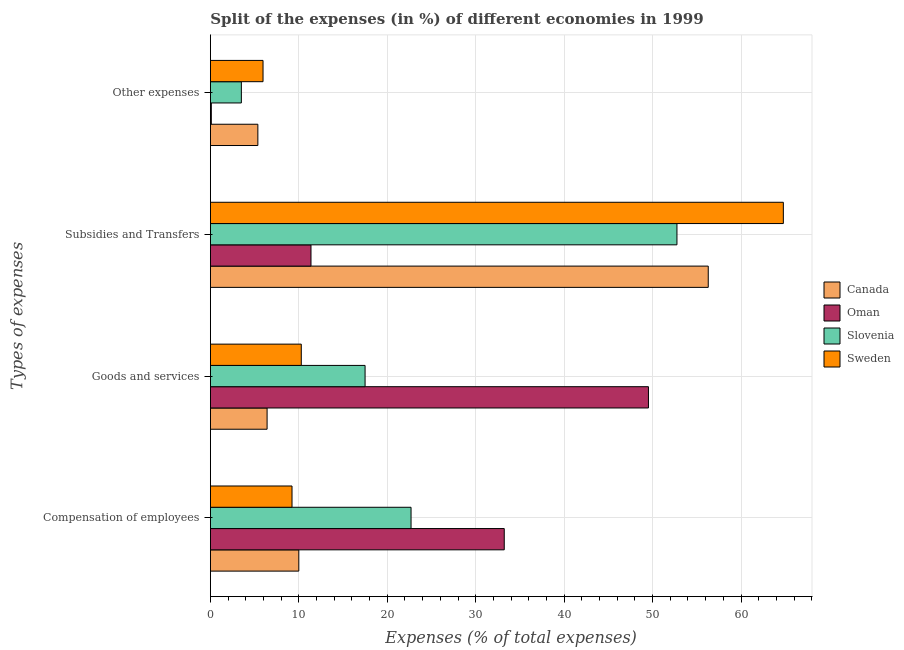Are the number of bars per tick equal to the number of legend labels?
Provide a short and direct response. Yes. How many bars are there on the 2nd tick from the top?
Offer a very short reply. 4. How many bars are there on the 1st tick from the bottom?
Offer a very short reply. 4. What is the label of the 1st group of bars from the top?
Give a very brief answer. Other expenses. What is the percentage of amount spent on subsidies in Slovenia?
Keep it short and to the point. 52.75. Across all countries, what is the maximum percentage of amount spent on subsidies?
Your response must be concise. 64.78. Across all countries, what is the minimum percentage of amount spent on goods and services?
Your answer should be compact. 6.41. In which country was the percentage of amount spent on goods and services maximum?
Your answer should be compact. Oman. In which country was the percentage of amount spent on other expenses minimum?
Make the answer very short. Oman. What is the total percentage of amount spent on other expenses in the graph?
Your response must be concise. 14.93. What is the difference between the percentage of amount spent on other expenses in Sweden and that in Slovenia?
Ensure brevity in your answer.  2.45. What is the difference between the percentage of amount spent on goods and services in Slovenia and the percentage of amount spent on other expenses in Sweden?
Provide a succinct answer. 11.54. What is the average percentage of amount spent on other expenses per country?
Your response must be concise. 3.73. What is the difference between the percentage of amount spent on goods and services and percentage of amount spent on other expenses in Sweden?
Keep it short and to the point. 4.32. What is the ratio of the percentage of amount spent on subsidies in Slovenia to that in Oman?
Provide a short and direct response. 4.64. Is the percentage of amount spent on other expenses in Oman less than that in Slovenia?
Provide a succinct answer. Yes. Is the difference between the percentage of amount spent on compensation of employees in Sweden and Oman greater than the difference between the percentage of amount spent on goods and services in Sweden and Oman?
Make the answer very short. Yes. What is the difference between the highest and the second highest percentage of amount spent on other expenses?
Offer a very short reply. 0.58. What is the difference between the highest and the lowest percentage of amount spent on compensation of employees?
Your answer should be compact. 24. What does the 1st bar from the top in Subsidies and Transfers represents?
Keep it short and to the point. Sweden. What does the 1st bar from the bottom in Subsidies and Transfers represents?
Offer a very short reply. Canada. Is it the case that in every country, the sum of the percentage of amount spent on compensation of employees and percentage of amount spent on goods and services is greater than the percentage of amount spent on subsidies?
Provide a succinct answer. No. How many bars are there?
Provide a short and direct response. 16. Are all the bars in the graph horizontal?
Your answer should be compact. Yes. What is the difference between two consecutive major ticks on the X-axis?
Provide a succinct answer. 10. Does the graph contain any zero values?
Ensure brevity in your answer.  No. Where does the legend appear in the graph?
Offer a terse response. Center right. How are the legend labels stacked?
Your response must be concise. Vertical. What is the title of the graph?
Offer a terse response. Split of the expenses (in %) of different economies in 1999. Does "Barbados" appear as one of the legend labels in the graph?
Offer a very short reply. No. What is the label or title of the X-axis?
Keep it short and to the point. Expenses (% of total expenses). What is the label or title of the Y-axis?
Ensure brevity in your answer.  Types of expenses. What is the Expenses (% of total expenses) of Canada in Compensation of employees?
Give a very brief answer. 10. What is the Expenses (% of total expenses) of Oman in Compensation of employees?
Give a very brief answer. 33.23. What is the Expenses (% of total expenses) of Slovenia in Compensation of employees?
Ensure brevity in your answer.  22.69. What is the Expenses (% of total expenses) in Sweden in Compensation of employees?
Offer a terse response. 9.23. What is the Expenses (% of total expenses) of Canada in Goods and services?
Offer a terse response. 6.41. What is the Expenses (% of total expenses) of Oman in Goods and services?
Provide a succinct answer. 49.53. What is the Expenses (% of total expenses) in Slovenia in Goods and services?
Give a very brief answer. 17.49. What is the Expenses (% of total expenses) in Sweden in Goods and services?
Your answer should be very brief. 10.28. What is the Expenses (% of total expenses) in Canada in Subsidies and Transfers?
Provide a succinct answer. 56.29. What is the Expenses (% of total expenses) of Oman in Subsidies and Transfers?
Your answer should be very brief. 11.37. What is the Expenses (% of total expenses) in Slovenia in Subsidies and Transfers?
Ensure brevity in your answer.  52.75. What is the Expenses (% of total expenses) of Sweden in Subsidies and Transfers?
Your response must be concise. 64.78. What is the Expenses (% of total expenses) in Canada in Other expenses?
Ensure brevity in your answer.  5.37. What is the Expenses (% of total expenses) in Oman in Other expenses?
Give a very brief answer. 0.1. What is the Expenses (% of total expenses) of Slovenia in Other expenses?
Your response must be concise. 3.5. What is the Expenses (% of total expenses) in Sweden in Other expenses?
Give a very brief answer. 5.95. Across all Types of expenses, what is the maximum Expenses (% of total expenses) of Canada?
Give a very brief answer. 56.29. Across all Types of expenses, what is the maximum Expenses (% of total expenses) in Oman?
Your answer should be very brief. 49.53. Across all Types of expenses, what is the maximum Expenses (% of total expenses) in Slovenia?
Your answer should be compact. 52.75. Across all Types of expenses, what is the maximum Expenses (% of total expenses) of Sweden?
Offer a very short reply. 64.78. Across all Types of expenses, what is the minimum Expenses (% of total expenses) in Canada?
Provide a short and direct response. 5.37. Across all Types of expenses, what is the minimum Expenses (% of total expenses) in Oman?
Keep it short and to the point. 0.1. Across all Types of expenses, what is the minimum Expenses (% of total expenses) in Slovenia?
Offer a very short reply. 3.5. Across all Types of expenses, what is the minimum Expenses (% of total expenses) in Sweden?
Make the answer very short. 5.95. What is the total Expenses (% of total expenses) of Canada in the graph?
Your answer should be compact. 78.07. What is the total Expenses (% of total expenses) in Oman in the graph?
Ensure brevity in your answer.  94.24. What is the total Expenses (% of total expenses) of Slovenia in the graph?
Offer a very short reply. 96.43. What is the total Expenses (% of total expenses) of Sweden in the graph?
Provide a short and direct response. 90.24. What is the difference between the Expenses (% of total expenses) in Canada in Compensation of employees and that in Goods and services?
Offer a very short reply. 3.59. What is the difference between the Expenses (% of total expenses) of Oman in Compensation of employees and that in Goods and services?
Your answer should be very brief. -16.3. What is the difference between the Expenses (% of total expenses) of Slovenia in Compensation of employees and that in Goods and services?
Give a very brief answer. 5.2. What is the difference between the Expenses (% of total expenses) of Sweden in Compensation of employees and that in Goods and services?
Your response must be concise. -1.05. What is the difference between the Expenses (% of total expenses) of Canada in Compensation of employees and that in Subsidies and Transfers?
Keep it short and to the point. -46.3. What is the difference between the Expenses (% of total expenses) in Oman in Compensation of employees and that in Subsidies and Transfers?
Give a very brief answer. 21.85. What is the difference between the Expenses (% of total expenses) in Slovenia in Compensation of employees and that in Subsidies and Transfers?
Your answer should be very brief. -30.07. What is the difference between the Expenses (% of total expenses) in Sweden in Compensation of employees and that in Subsidies and Transfers?
Ensure brevity in your answer.  -55.55. What is the difference between the Expenses (% of total expenses) in Canada in Compensation of employees and that in Other expenses?
Your answer should be very brief. 4.63. What is the difference between the Expenses (% of total expenses) of Oman in Compensation of employees and that in Other expenses?
Your answer should be very brief. 33.12. What is the difference between the Expenses (% of total expenses) of Slovenia in Compensation of employees and that in Other expenses?
Provide a short and direct response. 19.19. What is the difference between the Expenses (% of total expenses) of Sweden in Compensation of employees and that in Other expenses?
Ensure brevity in your answer.  3.28. What is the difference between the Expenses (% of total expenses) in Canada in Goods and services and that in Subsidies and Transfers?
Offer a very short reply. -49.88. What is the difference between the Expenses (% of total expenses) in Oman in Goods and services and that in Subsidies and Transfers?
Your answer should be very brief. 38.16. What is the difference between the Expenses (% of total expenses) of Slovenia in Goods and services and that in Subsidies and Transfers?
Ensure brevity in your answer.  -35.26. What is the difference between the Expenses (% of total expenses) in Sweden in Goods and services and that in Subsidies and Transfers?
Ensure brevity in your answer.  -54.51. What is the difference between the Expenses (% of total expenses) of Canada in Goods and services and that in Other expenses?
Make the answer very short. 1.04. What is the difference between the Expenses (% of total expenses) in Oman in Goods and services and that in Other expenses?
Keep it short and to the point. 49.43. What is the difference between the Expenses (% of total expenses) in Slovenia in Goods and services and that in Other expenses?
Your response must be concise. 13.99. What is the difference between the Expenses (% of total expenses) of Sweden in Goods and services and that in Other expenses?
Offer a very short reply. 4.32. What is the difference between the Expenses (% of total expenses) of Canada in Subsidies and Transfers and that in Other expenses?
Your response must be concise. 50.93. What is the difference between the Expenses (% of total expenses) in Oman in Subsidies and Transfers and that in Other expenses?
Your answer should be compact. 11.27. What is the difference between the Expenses (% of total expenses) of Slovenia in Subsidies and Transfers and that in Other expenses?
Your answer should be very brief. 49.25. What is the difference between the Expenses (% of total expenses) of Sweden in Subsidies and Transfers and that in Other expenses?
Ensure brevity in your answer.  58.83. What is the difference between the Expenses (% of total expenses) of Canada in Compensation of employees and the Expenses (% of total expenses) of Oman in Goods and services?
Provide a short and direct response. -39.53. What is the difference between the Expenses (% of total expenses) in Canada in Compensation of employees and the Expenses (% of total expenses) in Slovenia in Goods and services?
Provide a short and direct response. -7.49. What is the difference between the Expenses (% of total expenses) in Canada in Compensation of employees and the Expenses (% of total expenses) in Sweden in Goods and services?
Ensure brevity in your answer.  -0.28. What is the difference between the Expenses (% of total expenses) in Oman in Compensation of employees and the Expenses (% of total expenses) in Slovenia in Goods and services?
Provide a short and direct response. 15.74. What is the difference between the Expenses (% of total expenses) of Oman in Compensation of employees and the Expenses (% of total expenses) of Sweden in Goods and services?
Make the answer very short. 22.95. What is the difference between the Expenses (% of total expenses) in Slovenia in Compensation of employees and the Expenses (% of total expenses) in Sweden in Goods and services?
Ensure brevity in your answer.  12.41. What is the difference between the Expenses (% of total expenses) of Canada in Compensation of employees and the Expenses (% of total expenses) of Oman in Subsidies and Transfers?
Provide a short and direct response. -1.38. What is the difference between the Expenses (% of total expenses) of Canada in Compensation of employees and the Expenses (% of total expenses) of Slovenia in Subsidies and Transfers?
Make the answer very short. -42.76. What is the difference between the Expenses (% of total expenses) of Canada in Compensation of employees and the Expenses (% of total expenses) of Sweden in Subsidies and Transfers?
Ensure brevity in your answer.  -54.79. What is the difference between the Expenses (% of total expenses) of Oman in Compensation of employees and the Expenses (% of total expenses) of Slovenia in Subsidies and Transfers?
Offer a terse response. -19.53. What is the difference between the Expenses (% of total expenses) in Oman in Compensation of employees and the Expenses (% of total expenses) in Sweden in Subsidies and Transfers?
Give a very brief answer. -31.56. What is the difference between the Expenses (% of total expenses) in Slovenia in Compensation of employees and the Expenses (% of total expenses) in Sweden in Subsidies and Transfers?
Offer a terse response. -42.1. What is the difference between the Expenses (% of total expenses) in Canada in Compensation of employees and the Expenses (% of total expenses) in Oman in Other expenses?
Provide a short and direct response. 9.89. What is the difference between the Expenses (% of total expenses) of Canada in Compensation of employees and the Expenses (% of total expenses) of Slovenia in Other expenses?
Make the answer very short. 6.5. What is the difference between the Expenses (% of total expenses) of Canada in Compensation of employees and the Expenses (% of total expenses) of Sweden in Other expenses?
Provide a succinct answer. 4.05. What is the difference between the Expenses (% of total expenses) of Oman in Compensation of employees and the Expenses (% of total expenses) of Slovenia in Other expenses?
Keep it short and to the point. 29.72. What is the difference between the Expenses (% of total expenses) in Oman in Compensation of employees and the Expenses (% of total expenses) in Sweden in Other expenses?
Provide a succinct answer. 27.27. What is the difference between the Expenses (% of total expenses) in Slovenia in Compensation of employees and the Expenses (% of total expenses) in Sweden in Other expenses?
Your answer should be compact. 16.74. What is the difference between the Expenses (% of total expenses) of Canada in Goods and services and the Expenses (% of total expenses) of Oman in Subsidies and Transfers?
Keep it short and to the point. -4.96. What is the difference between the Expenses (% of total expenses) of Canada in Goods and services and the Expenses (% of total expenses) of Slovenia in Subsidies and Transfers?
Offer a terse response. -46.34. What is the difference between the Expenses (% of total expenses) of Canada in Goods and services and the Expenses (% of total expenses) of Sweden in Subsidies and Transfers?
Give a very brief answer. -58.37. What is the difference between the Expenses (% of total expenses) of Oman in Goods and services and the Expenses (% of total expenses) of Slovenia in Subsidies and Transfers?
Your answer should be compact. -3.22. What is the difference between the Expenses (% of total expenses) of Oman in Goods and services and the Expenses (% of total expenses) of Sweden in Subsidies and Transfers?
Make the answer very short. -15.25. What is the difference between the Expenses (% of total expenses) in Slovenia in Goods and services and the Expenses (% of total expenses) in Sweden in Subsidies and Transfers?
Provide a short and direct response. -47.29. What is the difference between the Expenses (% of total expenses) in Canada in Goods and services and the Expenses (% of total expenses) in Oman in Other expenses?
Provide a short and direct response. 6.31. What is the difference between the Expenses (% of total expenses) of Canada in Goods and services and the Expenses (% of total expenses) of Slovenia in Other expenses?
Keep it short and to the point. 2.91. What is the difference between the Expenses (% of total expenses) of Canada in Goods and services and the Expenses (% of total expenses) of Sweden in Other expenses?
Ensure brevity in your answer.  0.46. What is the difference between the Expenses (% of total expenses) in Oman in Goods and services and the Expenses (% of total expenses) in Slovenia in Other expenses?
Your answer should be very brief. 46.03. What is the difference between the Expenses (% of total expenses) of Oman in Goods and services and the Expenses (% of total expenses) of Sweden in Other expenses?
Provide a succinct answer. 43.58. What is the difference between the Expenses (% of total expenses) of Slovenia in Goods and services and the Expenses (% of total expenses) of Sweden in Other expenses?
Give a very brief answer. 11.54. What is the difference between the Expenses (% of total expenses) in Canada in Subsidies and Transfers and the Expenses (% of total expenses) in Oman in Other expenses?
Offer a very short reply. 56.19. What is the difference between the Expenses (% of total expenses) of Canada in Subsidies and Transfers and the Expenses (% of total expenses) of Slovenia in Other expenses?
Offer a terse response. 52.79. What is the difference between the Expenses (% of total expenses) in Canada in Subsidies and Transfers and the Expenses (% of total expenses) in Sweden in Other expenses?
Offer a very short reply. 50.34. What is the difference between the Expenses (% of total expenses) of Oman in Subsidies and Transfers and the Expenses (% of total expenses) of Slovenia in Other expenses?
Provide a succinct answer. 7.87. What is the difference between the Expenses (% of total expenses) in Oman in Subsidies and Transfers and the Expenses (% of total expenses) in Sweden in Other expenses?
Give a very brief answer. 5.42. What is the difference between the Expenses (% of total expenses) in Slovenia in Subsidies and Transfers and the Expenses (% of total expenses) in Sweden in Other expenses?
Your response must be concise. 46.8. What is the average Expenses (% of total expenses) in Canada per Types of expenses?
Make the answer very short. 19.52. What is the average Expenses (% of total expenses) of Oman per Types of expenses?
Make the answer very short. 23.56. What is the average Expenses (% of total expenses) in Slovenia per Types of expenses?
Offer a terse response. 24.11. What is the average Expenses (% of total expenses) of Sweden per Types of expenses?
Provide a short and direct response. 22.56. What is the difference between the Expenses (% of total expenses) of Canada and Expenses (% of total expenses) of Oman in Compensation of employees?
Provide a succinct answer. -23.23. What is the difference between the Expenses (% of total expenses) in Canada and Expenses (% of total expenses) in Slovenia in Compensation of employees?
Your answer should be very brief. -12.69. What is the difference between the Expenses (% of total expenses) in Canada and Expenses (% of total expenses) in Sweden in Compensation of employees?
Provide a short and direct response. 0.77. What is the difference between the Expenses (% of total expenses) in Oman and Expenses (% of total expenses) in Slovenia in Compensation of employees?
Offer a very short reply. 10.54. What is the difference between the Expenses (% of total expenses) of Oman and Expenses (% of total expenses) of Sweden in Compensation of employees?
Provide a short and direct response. 24. What is the difference between the Expenses (% of total expenses) of Slovenia and Expenses (% of total expenses) of Sweden in Compensation of employees?
Make the answer very short. 13.46. What is the difference between the Expenses (% of total expenses) in Canada and Expenses (% of total expenses) in Oman in Goods and services?
Offer a terse response. -43.12. What is the difference between the Expenses (% of total expenses) of Canada and Expenses (% of total expenses) of Slovenia in Goods and services?
Keep it short and to the point. -11.08. What is the difference between the Expenses (% of total expenses) of Canada and Expenses (% of total expenses) of Sweden in Goods and services?
Provide a succinct answer. -3.87. What is the difference between the Expenses (% of total expenses) of Oman and Expenses (% of total expenses) of Slovenia in Goods and services?
Provide a short and direct response. 32.04. What is the difference between the Expenses (% of total expenses) in Oman and Expenses (% of total expenses) in Sweden in Goods and services?
Ensure brevity in your answer.  39.25. What is the difference between the Expenses (% of total expenses) in Slovenia and Expenses (% of total expenses) in Sweden in Goods and services?
Make the answer very short. 7.21. What is the difference between the Expenses (% of total expenses) in Canada and Expenses (% of total expenses) in Oman in Subsidies and Transfers?
Make the answer very short. 44.92. What is the difference between the Expenses (% of total expenses) of Canada and Expenses (% of total expenses) of Slovenia in Subsidies and Transfers?
Your response must be concise. 3.54. What is the difference between the Expenses (% of total expenses) in Canada and Expenses (% of total expenses) in Sweden in Subsidies and Transfers?
Your response must be concise. -8.49. What is the difference between the Expenses (% of total expenses) of Oman and Expenses (% of total expenses) of Slovenia in Subsidies and Transfers?
Make the answer very short. -41.38. What is the difference between the Expenses (% of total expenses) in Oman and Expenses (% of total expenses) in Sweden in Subsidies and Transfers?
Ensure brevity in your answer.  -53.41. What is the difference between the Expenses (% of total expenses) in Slovenia and Expenses (% of total expenses) in Sweden in Subsidies and Transfers?
Ensure brevity in your answer.  -12.03. What is the difference between the Expenses (% of total expenses) in Canada and Expenses (% of total expenses) in Oman in Other expenses?
Your answer should be very brief. 5.26. What is the difference between the Expenses (% of total expenses) in Canada and Expenses (% of total expenses) in Slovenia in Other expenses?
Give a very brief answer. 1.87. What is the difference between the Expenses (% of total expenses) in Canada and Expenses (% of total expenses) in Sweden in Other expenses?
Make the answer very short. -0.58. What is the difference between the Expenses (% of total expenses) in Oman and Expenses (% of total expenses) in Slovenia in Other expenses?
Provide a short and direct response. -3.4. What is the difference between the Expenses (% of total expenses) of Oman and Expenses (% of total expenses) of Sweden in Other expenses?
Your response must be concise. -5.85. What is the difference between the Expenses (% of total expenses) of Slovenia and Expenses (% of total expenses) of Sweden in Other expenses?
Your answer should be very brief. -2.45. What is the ratio of the Expenses (% of total expenses) in Canada in Compensation of employees to that in Goods and services?
Make the answer very short. 1.56. What is the ratio of the Expenses (% of total expenses) of Oman in Compensation of employees to that in Goods and services?
Ensure brevity in your answer.  0.67. What is the ratio of the Expenses (% of total expenses) of Slovenia in Compensation of employees to that in Goods and services?
Offer a very short reply. 1.3. What is the ratio of the Expenses (% of total expenses) in Sweden in Compensation of employees to that in Goods and services?
Provide a succinct answer. 0.9. What is the ratio of the Expenses (% of total expenses) of Canada in Compensation of employees to that in Subsidies and Transfers?
Provide a succinct answer. 0.18. What is the ratio of the Expenses (% of total expenses) in Oman in Compensation of employees to that in Subsidies and Transfers?
Your answer should be compact. 2.92. What is the ratio of the Expenses (% of total expenses) in Slovenia in Compensation of employees to that in Subsidies and Transfers?
Provide a short and direct response. 0.43. What is the ratio of the Expenses (% of total expenses) in Sweden in Compensation of employees to that in Subsidies and Transfers?
Offer a very short reply. 0.14. What is the ratio of the Expenses (% of total expenses) in Canada in Compensation of employees to that in Other expenses?
Provide a short and direct response. 1.86. What is the ratio of the Expenses (% of total expenses) of Oman in Compensation of employees to that in Other expenses?
Ensure brevity in your answer.  316.44. What is the ratio of the Expenses (% of total expenses) in Slovenia in Compensation of employees to that in Other expenses?
Ensure brevity in your answer.  6.48. What is the ratio of the Expenses (% of total expenses) in Sweden in Compensation of employees to that in Other expenses?
Make the answer very short. 1.55. What is the ratio of the Expenses (% of total expenses) in Canada in Goods and services to that in Subsidies and Transfers?
Your answer should be very brief. 0.11. What is the ratio of the Expenses (% of total expenses) of Oman in Goods and services to that in Subsidies and Transfers?
Keep it short and to the point. 4.35. What is the ratio of the Expenses (% of total expenses) in Slovenia in Goods and services to that in Subsidies and Transfers?
Your answer should be very brief. 0.33. What is the ratio of the Expenses (% of total expenses) of Sweden in Goods and services to that in Subsidies and Transfers?
Provide a short and direct response. 0.16. What is the ratio of the Expenses (% of total expenses) of Canada in Goods and services to that in Other expenses?
Offer a terse response. 1.19. What is the ratio of the Expenses (% of total expenses) of Oman in Goods and services to that in Other expenses?
Provide a short and direct response. 471.72. What is the ratio of the Expenses (% of total expenses) in Slovenia in Goods and services to that in Other expenses?
Your answer should be very brief. 4.99. What is the ratio of the Expenses (% of total expenses) in Sweden in Goods and services to that in Other expenses?
Keep it short and to the point. 1.73. What is the ratio of the Expenses (% of total expenses) of Canada in Subsidies and Transfers to that in Other expenses?
Your response must be concise. 10.49. What is the ratio of the Expenses (% of total expenses) in Oman in Subsidies and Transfers to that in Other expenses?
Offer a very short reply. 108.33. What is the ratio of the Expenses (% of total expenses) in Slovenia in Subsidies and Transfers to that in Other expenses?
Ensure brevity in your answer.  15.06. What is the ratio of the Expenses (% of total expenses) in Sweden in Subsidies and Transfers to that in Other expenses?
Ensure brevity in your answer.  10.88. What is the difference between the highest and the second highest Expenses (% of total expenses) in Canada?
Give a very brief answer. 46.3. What is the difference between the highest and the second highest Expenses (% of total expenses) of Oman?
Give a very brief answer. 16.3. What is the difference between the highest and the second highest Expenses (% of total expenses) of Slovenia?
Make the answer very short. 30.07. What is the difference between the highest and the second highest Expenses (% of total expenses) of Sweden?
Offer a terse response. 54.51. What is the difference between the highest and the lowest Expenses (% of total expenses) of Canada?
Offer a very short reply. 50.93. What is the difference between the highest and the lowest Expenses (% of total expenses) of Oman?
Give a very brief answer. 49.43. What is the difference between the highest and the lowest Expenses (% of total expenses) in Slovenia?
Provide a succinct answer. 49.25. What is the difference between the highest and the lowest Expenses (% of total expenses) of Sweden?
Your answer should be compact. 58.83. 